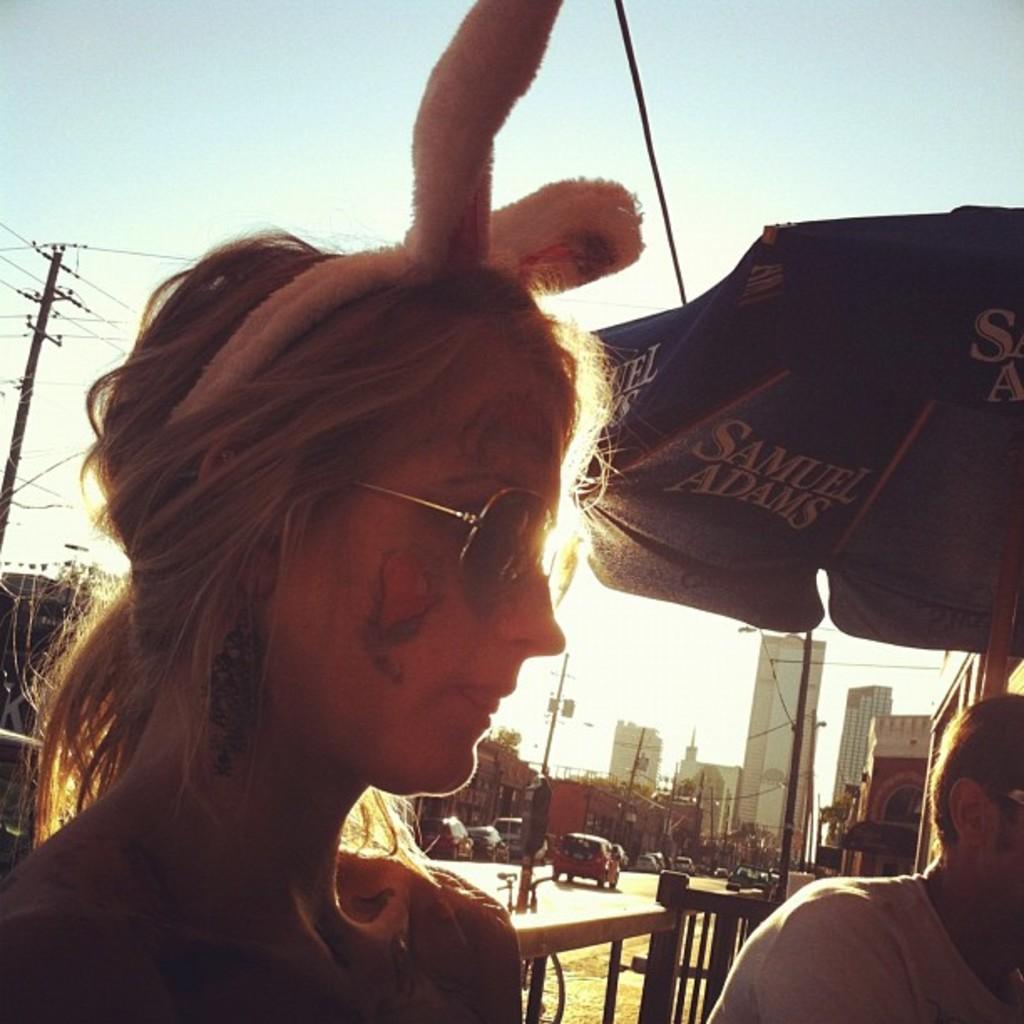Please provide a concise description of this image. In the center of the image we can see a person is wearing a headband and glasses. On the left side of the image, we can see one more person. In the background, we can see the sky, buildings, poles, one outdoor umbrella, vehicles and a few other objects. 